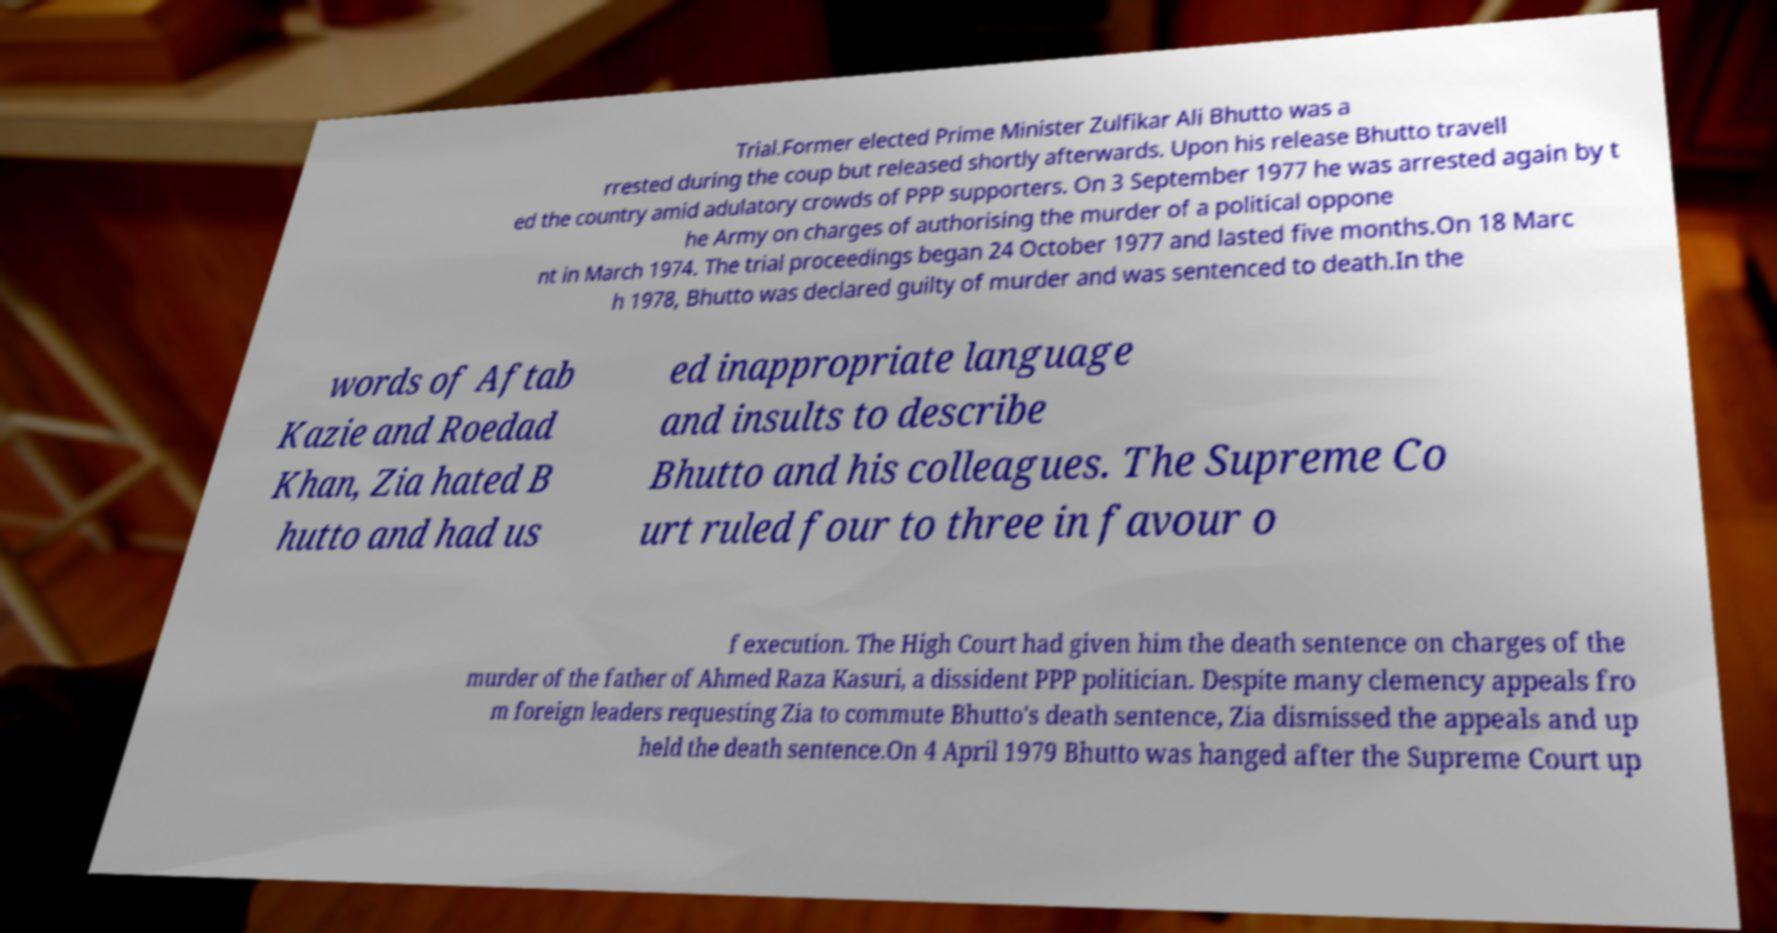Can you read and provide the text displayed in the image?This photo seems to have some interesting text. Can you extract and type it out for me? Trial.Former elected Prime Minister Zulfikar Ali Bhutto was a rrested during the coup but released shortly afterwards. Upon his release Bhutto travell ed the country amid adulatory crowds of PPP supporters. On 3 September 1977 he was arrested again by t he Army on charges of authorising the murder of a political oppone nt in March 1974. The trial proceedings began 24 October 1977 and lasted five months.On 18 Marc h 1978, Bhutto was declared guilty of murder and was sentenced to death.In the words of Aftab Kazie and Roedad Khan, Zia hated B hutto and had us ed inappropriate language and insults to describe Bhutto and his colleagues. The Supreme Co urt ruled four to three in favour o f execution. The High Court had given him the death sentence on charges of the murder of the father of Ahmed Raza Kasuri, a dissident PPP politician. Despite many clemency appeals fro m foreign leaders requesting Zia to commute Bhutto's death sentence, Zia dismissed the appeals and up held the death sentence.On 4 April 1979 Bhutto was hanged after the Supreme Court up 